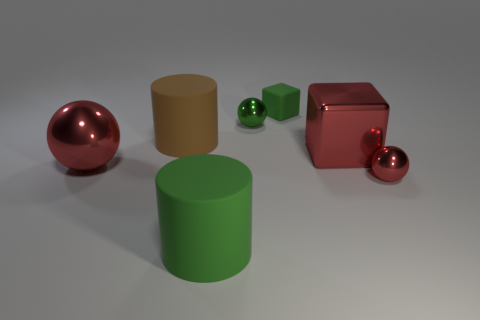Add 2 cyan shiny cylinders. How many objects exist? 9 Subtract all blocks. How many objects are left? 5 Add 1 green matte cubes. How many green matte cubes exist? 2 Subtract 0 blue spheres. How many objects are left? 7 Subtract all green rubber blocks. Subtract all shiny balls. How many objects are left? 3 Add 1 matte objects. How many matte objects are left? 4 